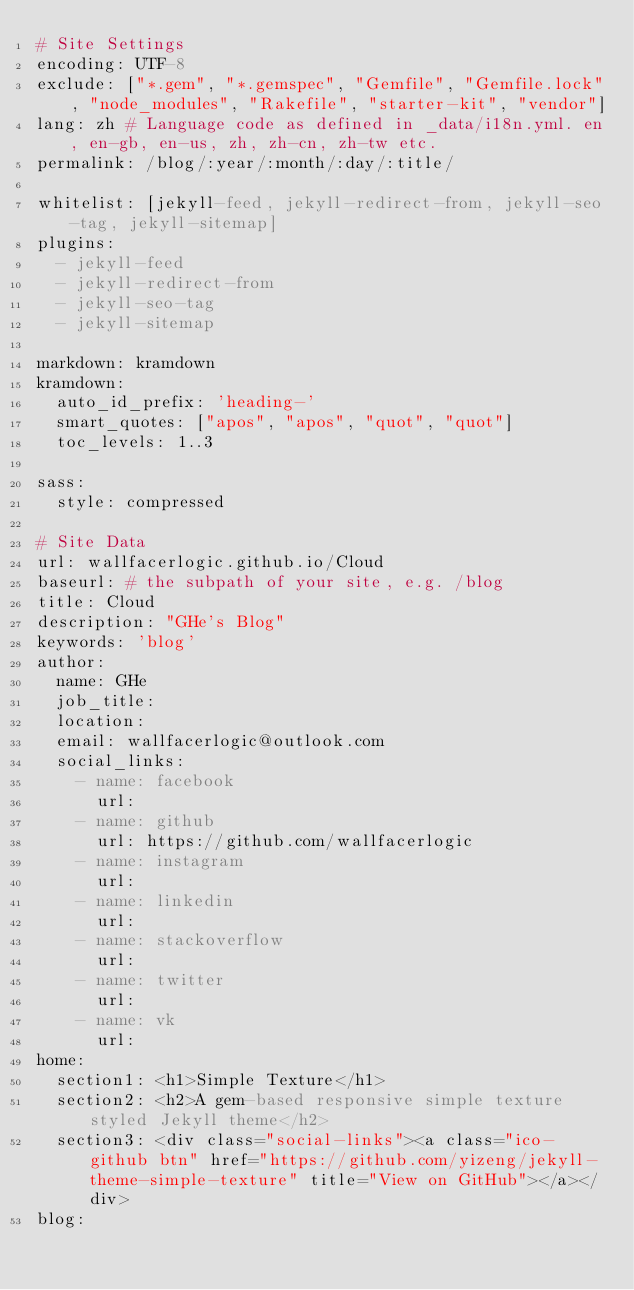Convert code to text. <code><loc_0><loc_0><loc_500><loc_500><_YAML_># Site Settings
encoding: UTF-8
exclude: ["*.gem", "*.gemspec", "Gemfile", "Gemfile.lock", "node_modules", "Rakefile", "starter-kit", "vendor"]
lang: zh # Language code as defined in _data/i18n.yml. en, en-gb, en-us, zh, zh-cn, zh-tw etc.
permalink: /blog/:year/:month/:day/:title/

whitelist: [jekyll-feed, jekyll-redirect-from, jekyll-seo-tag, jekyll-sitemap]
plugins:
  - jekyll-feed
  - jekyll-redirect-from
  - jekyll-seo-tag
  - jekyll-sitemap

markdown: kramdown
kramdown:
  auto_id_prefix: 'heading-'
  smart_quotes: ["apos", "apos", "quot", "quot"]
  toc_levels: 1..3

sass:
  style: compressed

# Site Data
url: wallfacerlogic.github.io/Cloud
baseurl: # the subpath of your site, e.g. /blog
title: Cloud
description: "GHe's Blog"
keywords: 'blog'
author:
  name: GHe
  job_title:
  location:
  email: wallfacerlogic@outlook.com
  social_links:
    - name: facebook
      url:
    - name: github
      url: https://github.com/wallfacerlogic
    - name: instagram
      url:
    - name: linkedin
      url:
    - name: stackoverflow
      url:
    - name: twitter
      url: 
    - name: vk
      url:
home:
  section1: <h1>Simple Texture</h1>
  section2: <h2>A gem-based responsive simple texture styled Jekyll theme</h2>
  section3: <div class="social-links"><a class="ico-github btn" href="https://github.com/yizeng/jekyll-theme-simple-texture" title="View on GitHub"></a></div>
blog:</code> 